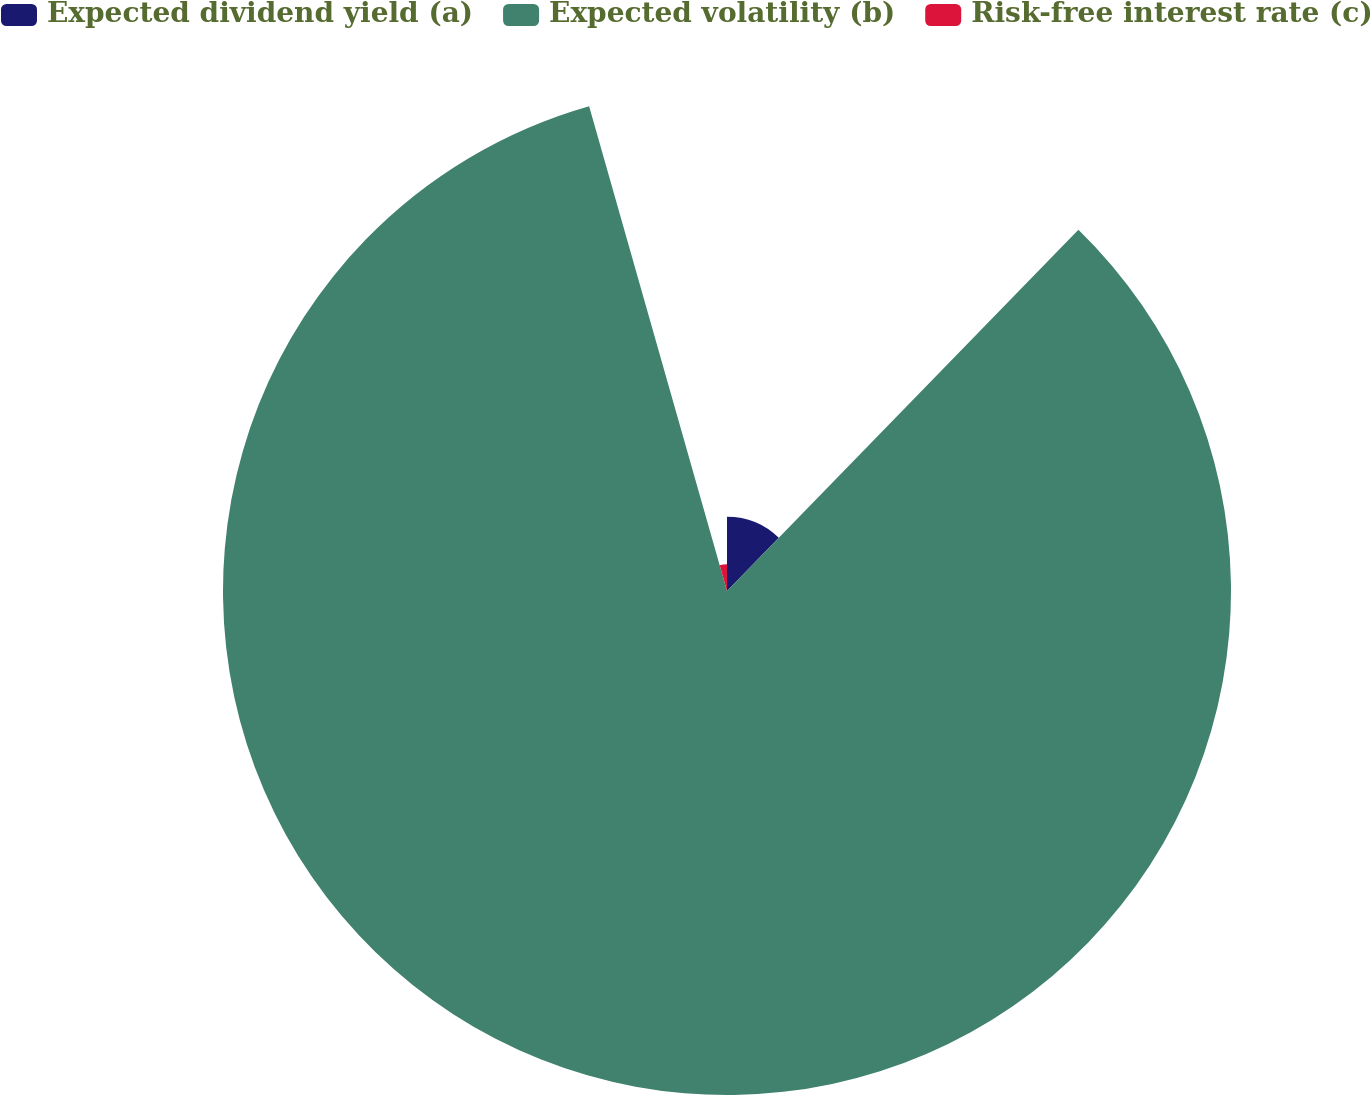Convert chart to OTSL. <chart><loc_0><loc_0><loc_500><loc_500><pie_chart><fcel>Expected dividend yield (a)<fcel>Expected volatility (b)<fcel>Risk-free interest rate (c)<nl><fcel>12.28%<fcel>83.31%<fcel>4.41%<nl></chart> 